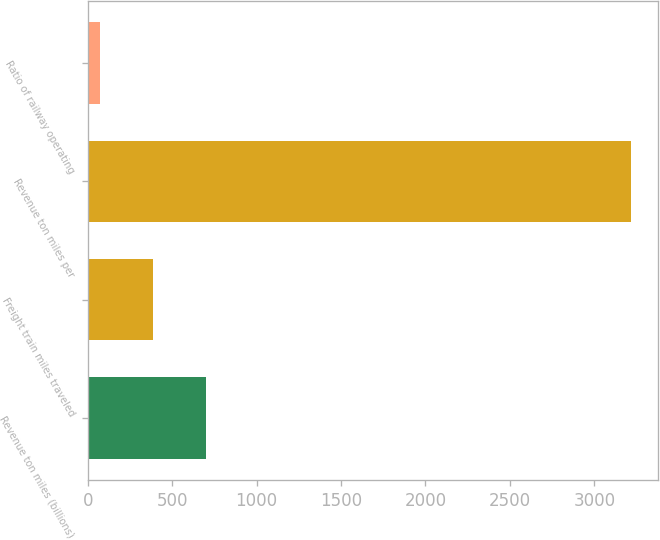Convert chart to OTSL. <chart><loc_0><loc_0><loc_500><loc_500><bar_chart><fcel>Revenue ton miles (billions)<fcel>Freight train miles traveled<fcel>Revenue ton miles per<fcel>Ratio of railway operating<nl><fcel>701.12<fcel>386.51<fcel>3218<fcel>71.9<nl></chart> 